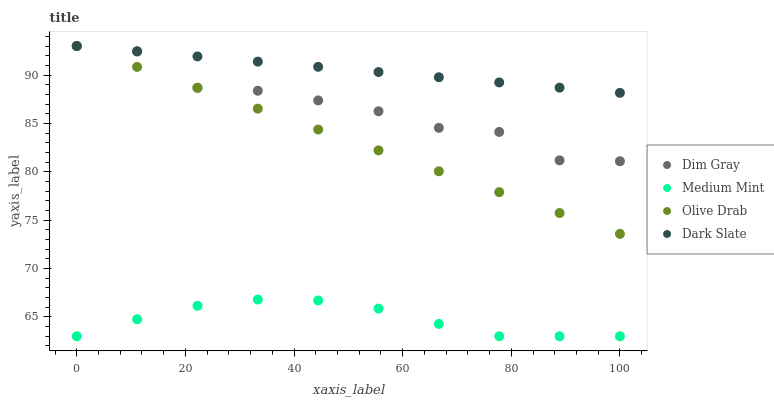Does Medium Mint have the minimum area under the curve?
Answer yes or no. Yes. Does Dark Slate have the maximum area under the curve?
Answer yes or no. Yes. Does Dim Gray have the minimum area under the curve?
Answer yes or no. No. Does Dim Gray have the maximum area under the curve?
Answer yes or no. No. Is Dark Slate the smoothest?
Answer yes or no. Yes. Is Dim Gray the roughest?
Answer yes or no. Yes. Is Dim Gray the smoothest?
Answer yes or no. No. Is Dark Slate the roughest?
Answer yes or no. No. Does Medium Mint have the lowest value?
Answer yes or no. Yes. Does Dim Gray have the lowest value?
Answer yes or no. No. Does Olive Drab have the highest value?
Answer yes or no. Yes. Is Medium Mint less than Olive Drab?
Answer yes or no. Yes. Is Olive Drab greater than Medium Mint?
Answer yes or no. Yes. Does Olive Drab intersect Dim Gray?
Answer yes or no. Yes. Is Olive Drab less than Dim Gray?
Answer yes or no. No. Is Olive Drab greater than Dim Gray?
Answer yes or no. No. Does Medium Mint intersect Olive Drab?
Answer yes or no. No. 